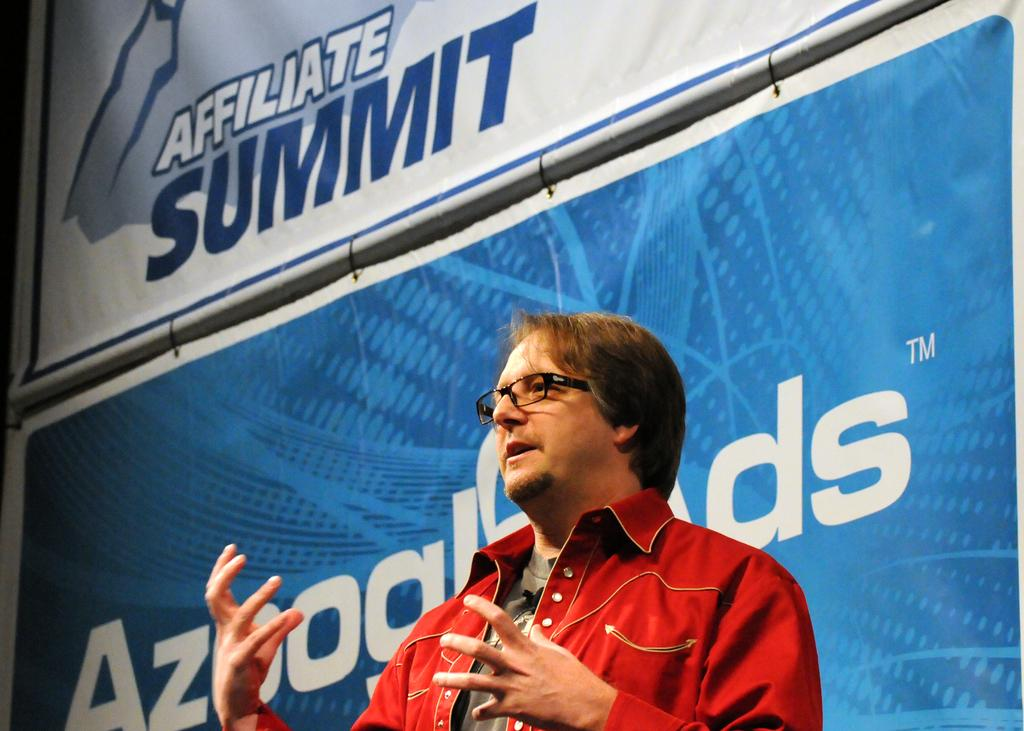Who or what is the main subject in the image? There is a person in the image. Where is the person located in the image? The person is at the bottom of the image. Can you describe anything that might be behind the person? There may be a banner behind the person. If there is a banner, what might be written on it? If there is a banner, it likely has text on it. What type of lamp is hanging above the person in the image? There is no lamp present in the image; it only features a person and possibly a banner. 